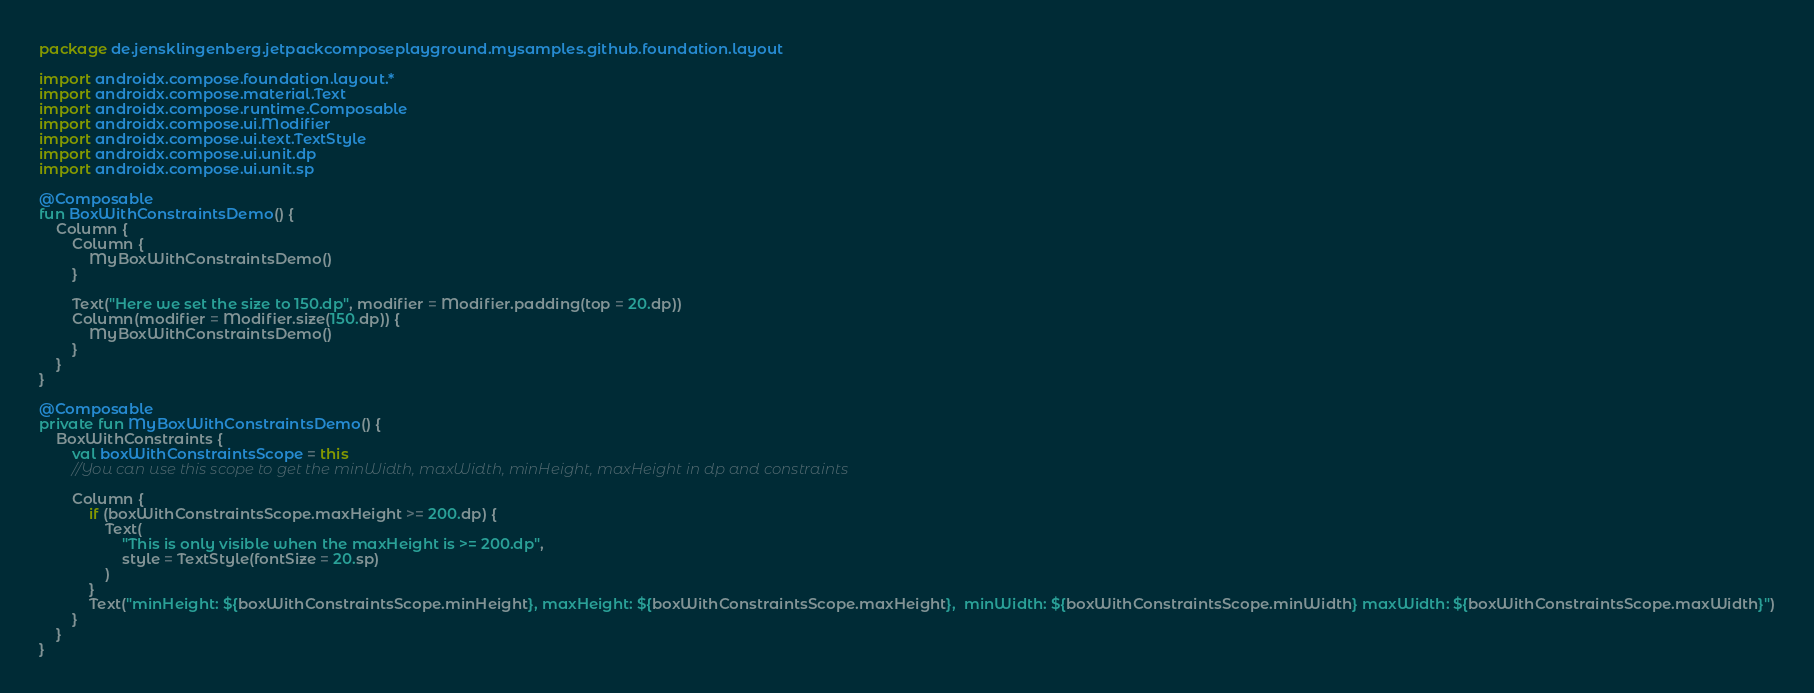Convert code to text. <code><loc_0><loc_0><loc_500><loc_500><_Kotlin_>package de.jensklingenberg.jetpackcomposeplayground.mysamples.github.foundation.layout

import androidx.compose.foundation.layout.*
import androidx.compose.material.Text
import androidx.compose.runtime.Composable
import androidx.compose.ui.Modifier
import androidx.compose.ui.text.TextStyle
import androidx.compose.ui.unit.dp
import androidx.compose.ui.unit.sp

@Composable
fun BoxWithConstraintsDemo() {
    Column {
        Column {
            MyBoxWithConstraintsDemo()
        }

        Text("Here we set the size to 150.dp", modifier = Modifier.padding(top = 20.dp))
        Column(modifier = Modifier.size(150.dp)) {
            MyBoxWithConstraintsDemo()
        }
    }
}

@Composable
private fun MyBoxWithConstraintsDemo() {
    BoxWithConstraints {
        val boxWithConstraintsScope = this
        //You can use this scope to get the minWidth, maxWidth, minHeight, maxHeight in dp and constraints

        Column {
            if (boxWithConstraintsScope.maxHeight >= 200.dp) {
                Text(
                    "This is only visible when the maxHeight is >= 200.dp",
                    style = TextStyle(fontSize = 20.sp)
                )
            }
            Text("minHeight: ${boxWithConstraintsScope.minHeight}, maxHeight: ${boxWithConstraintsScope.maxHeight},  minWidth: ${boxWithConstraintsScope.minWidth} maxWidth: ${boxWithConstraintsScope.maxWidth}")
        }
    }
}</code> 